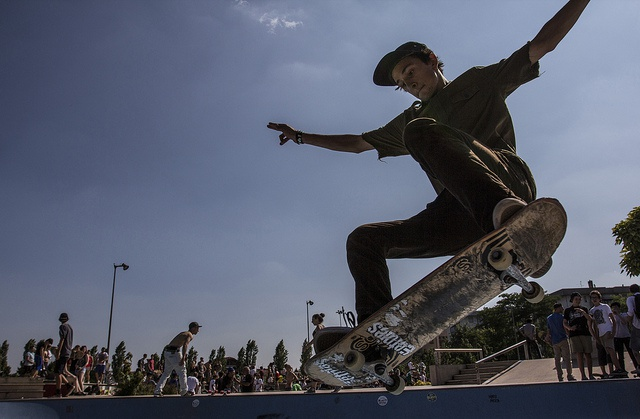Describe the objects in this image and their specific colors. I can see people in black, gray, and darkgray tones, skateboard in black and gray tones, people in black, gray, and darkgray tones, people in black and gray tones, and people in black, gray, and darkgray tones in this image. 